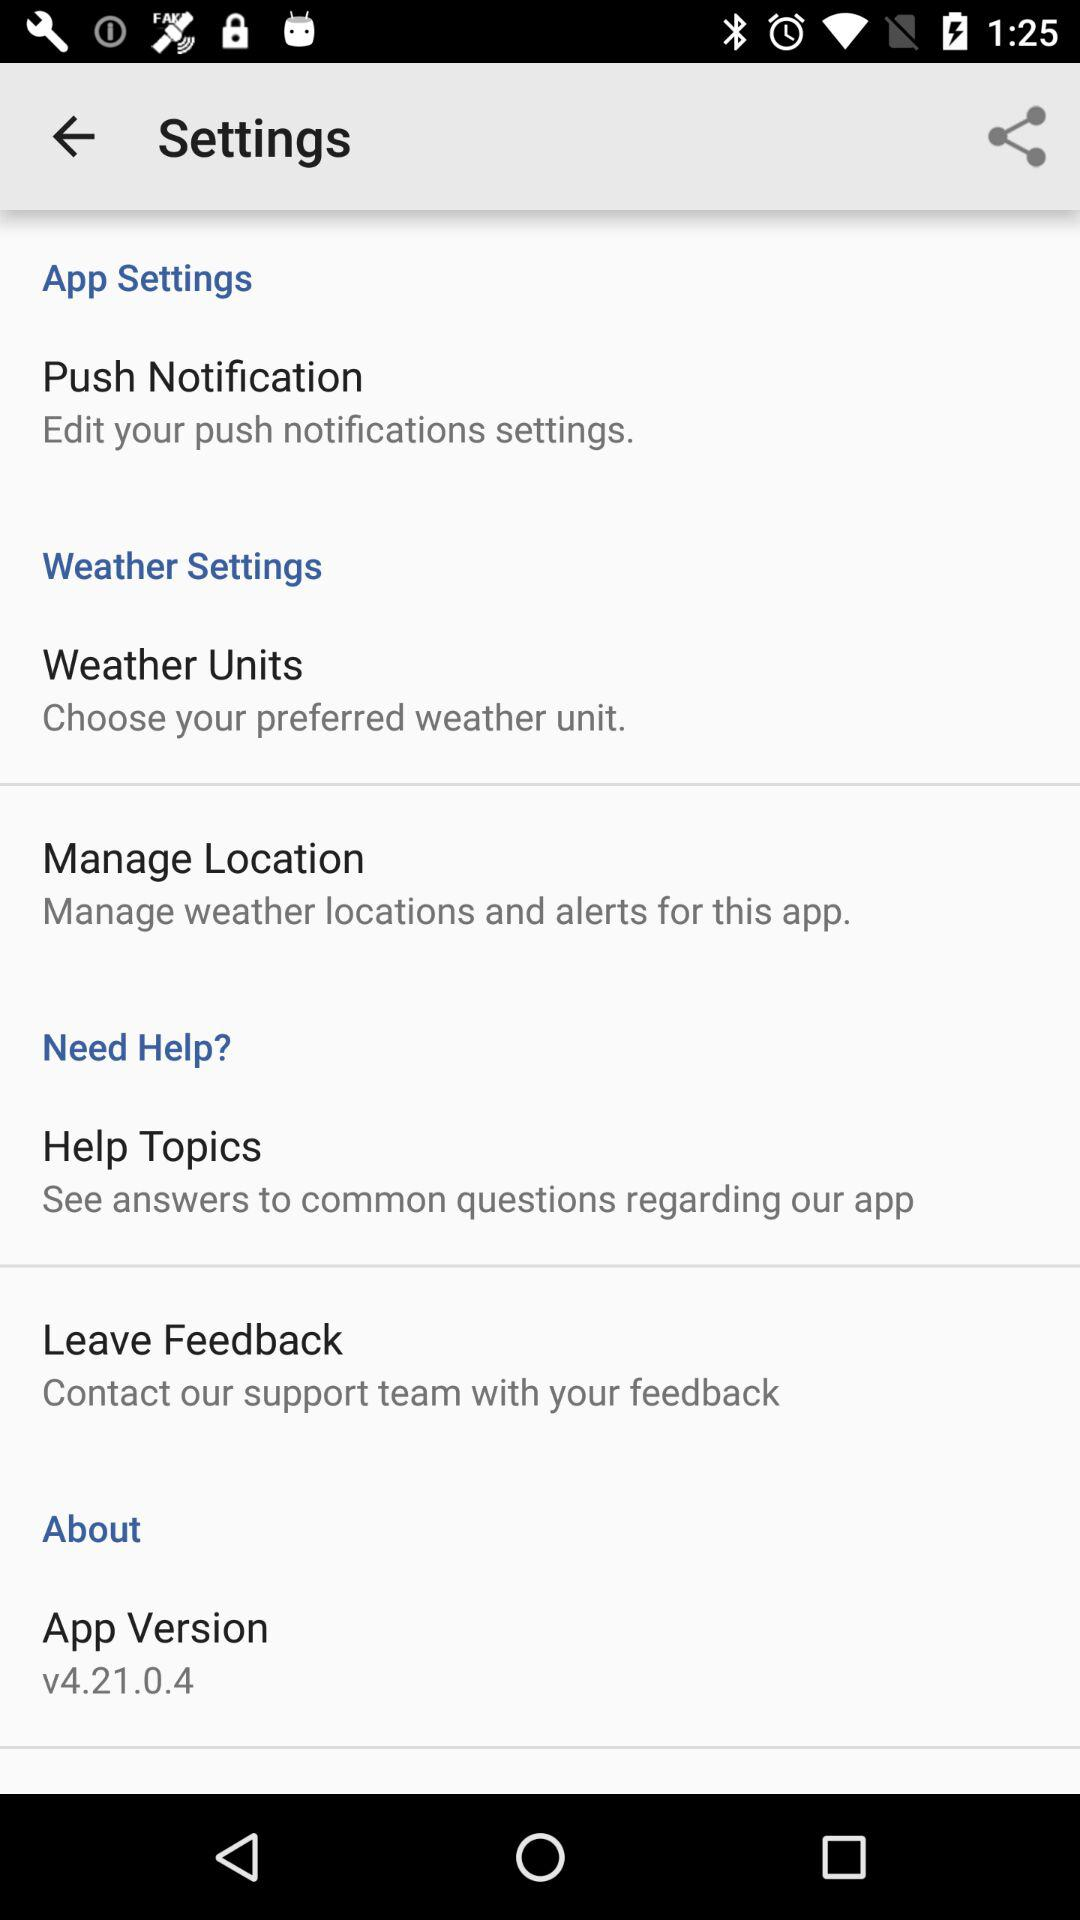What team should we contact to leave our feedback? You should contact the support team to leave your feedback. 